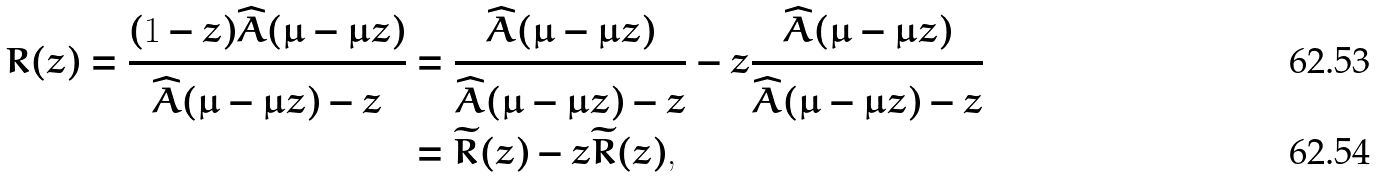Convert formula to latex. <formula><loc_0><loc_0><loc_500><loc_500>R ( z ) = \frac { ( 1 - z ) \widehat { A } ( \mu - \mu z ) } { \widehat { A } ( \mu - \mu z ) - z } & = \frac { \widehat { A } ( \mu - \mu z ) } { \widehat { A } ( \mu - \mu z ) - z } - z \frac { \widehat { A } ( \mu - \mu z ) } { \widehat { A } ( \mu - \mu z ) - z } \\ & = \widetilde { R } ( z ) - z \widetilde { R } ( z ) ,</formula> 